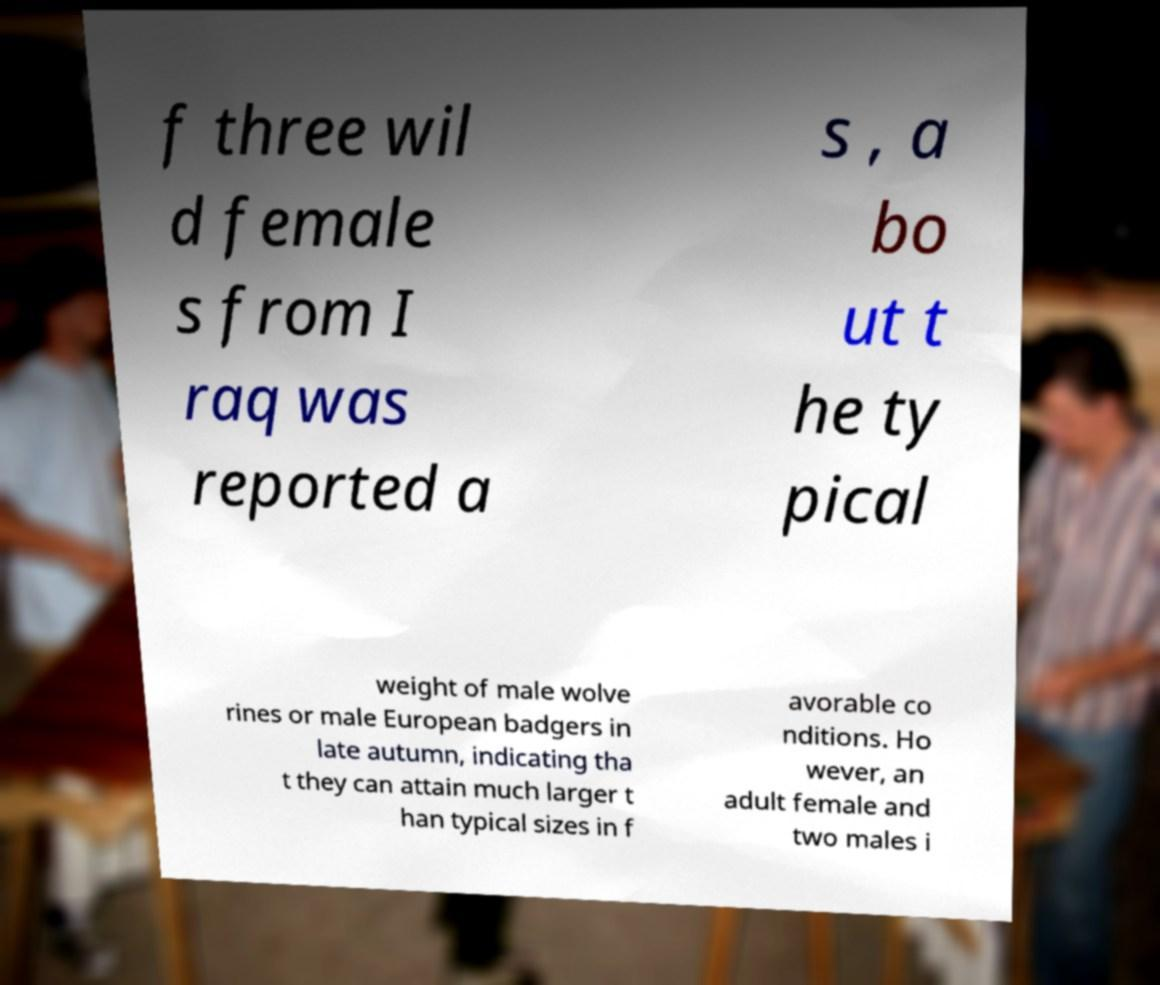Please read and relay the text visible in this image. What does it say? f three wil d female s from I raq was reported a s , a bo ut t he ty pical weight of male wolve rines or male European badgers in late autumn, indicating tha t they can attain much larger t han typical sizes in f avorable co nditions. Ho wever, an adult female and two males i 